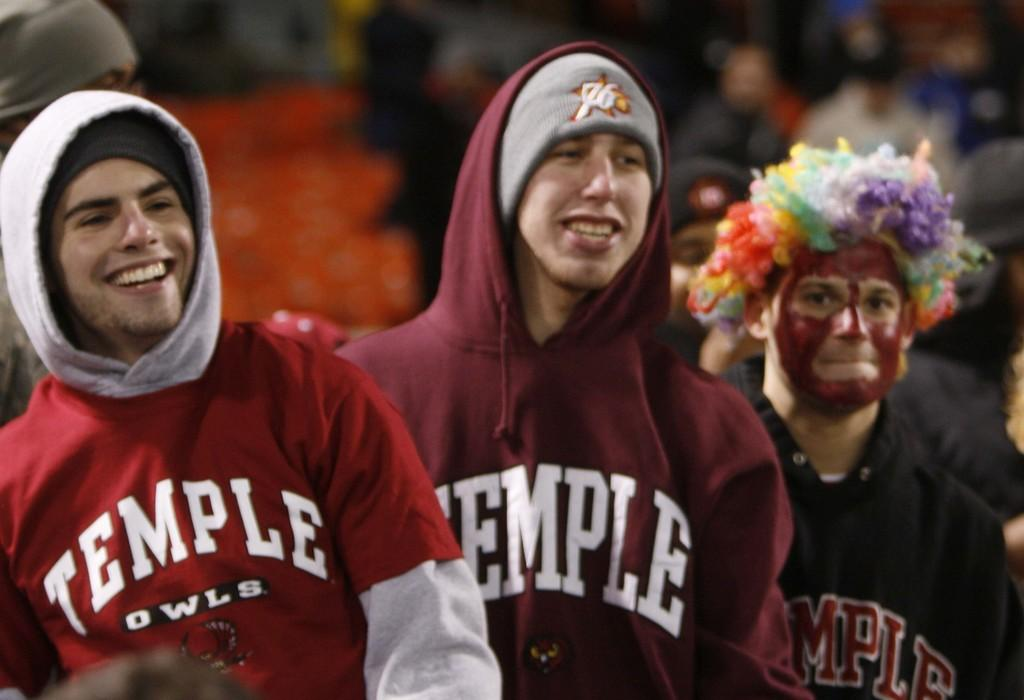<image>
Offer a succinct explanation of the picture presented. A group of people all wearing sweatshirts with the word temple on them. 